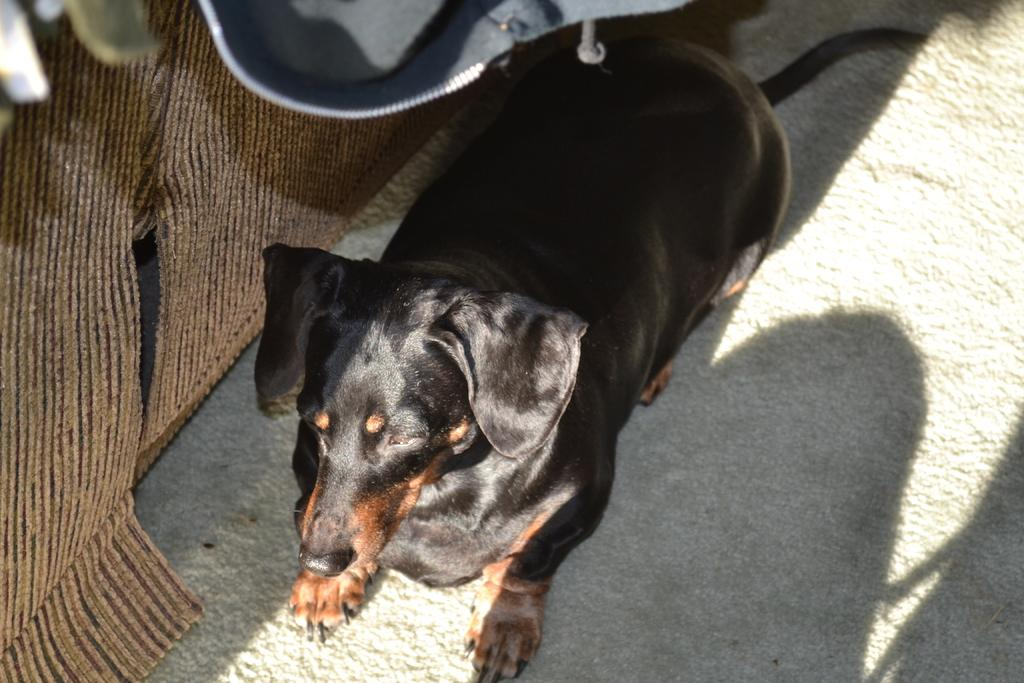What type of animal is in the image? There is a black dog in the image. What else can be observed in the image besides the dog? Shadows are visible in the image. What is the title of the shop in the image? There is no shop present in the image, so there is no title to reference. 